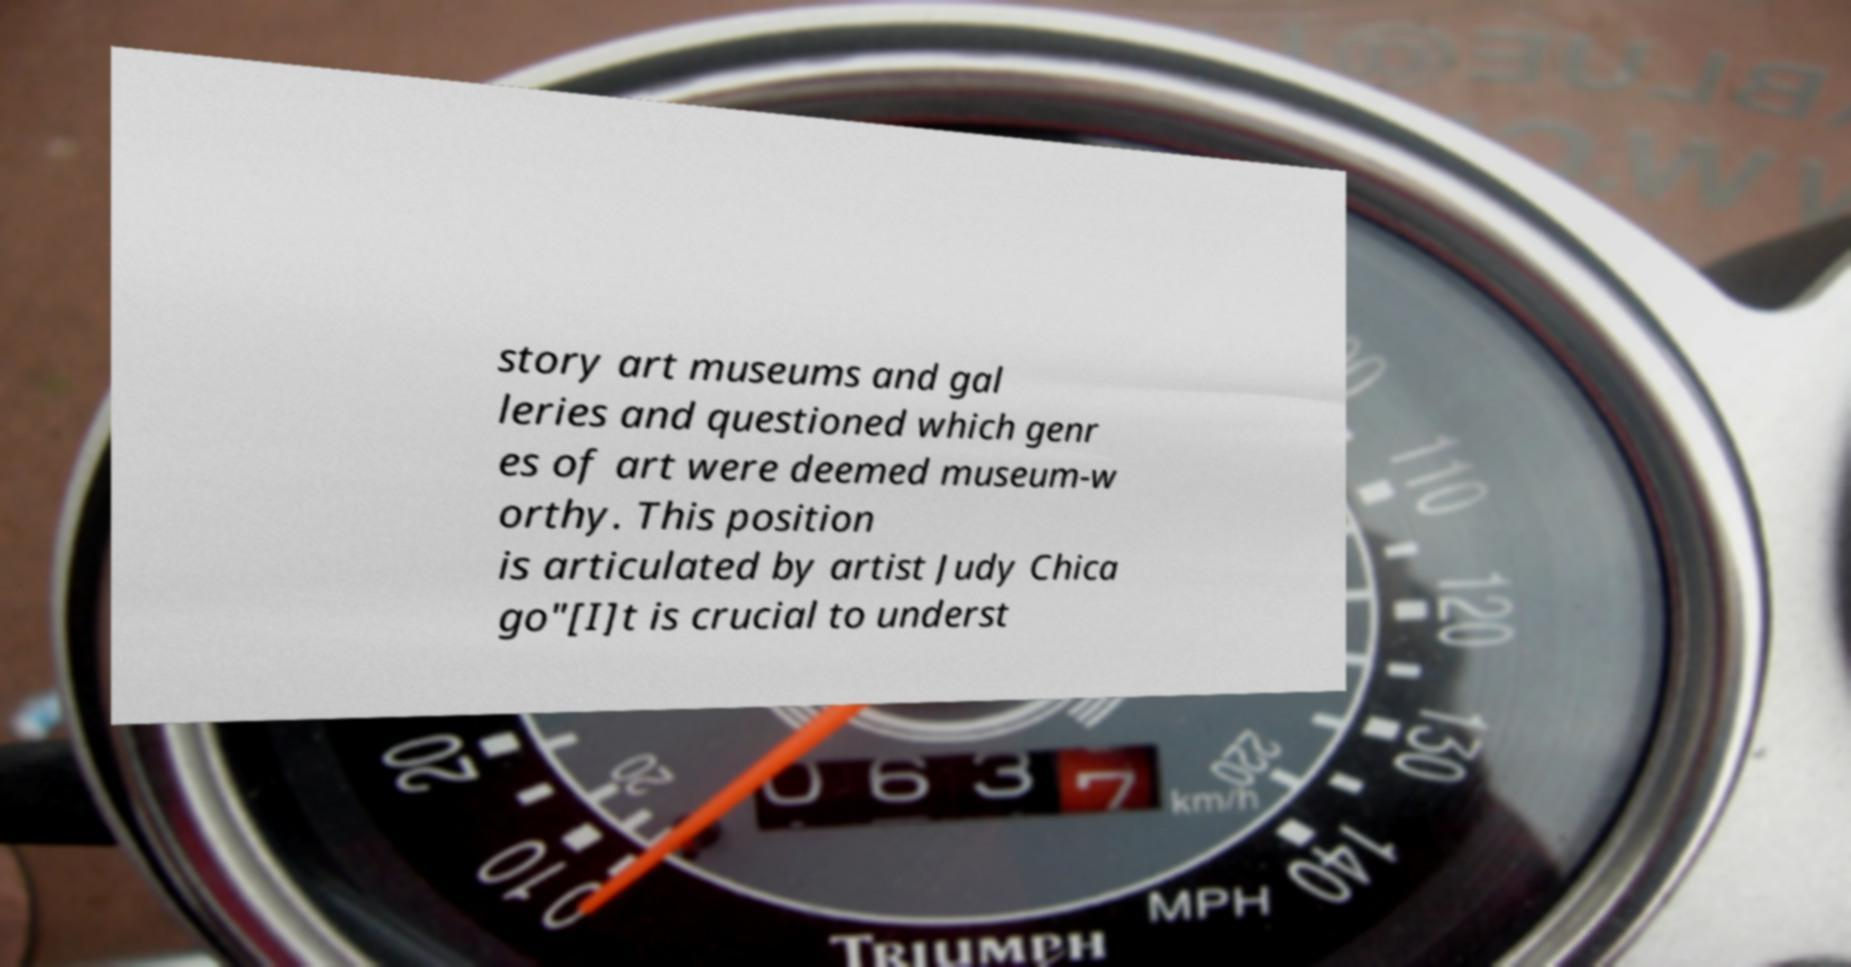There's text embedded in this image that I need extracted. Can you transcribe it verbatim? story art museums and gal leries and questioned which genr es of art were deemed museum-w orthy. This position is articulated by artist Judy Chica go"[I]t is crucial to underst 